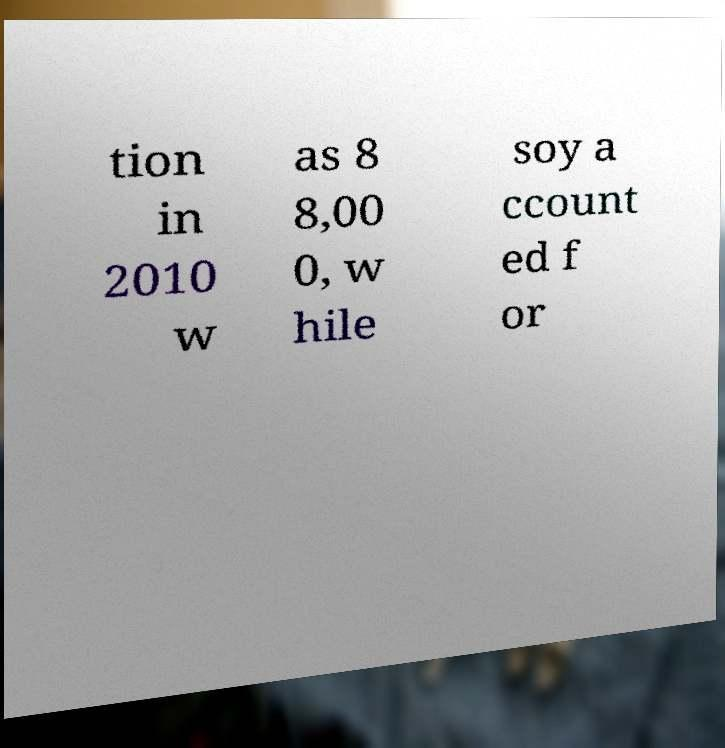There's text embedded in this image that I need extracted. Can you transcribe it verbatim? tion in 2010 w as 8 8,00 0, w hile soy a ccount ed f or 